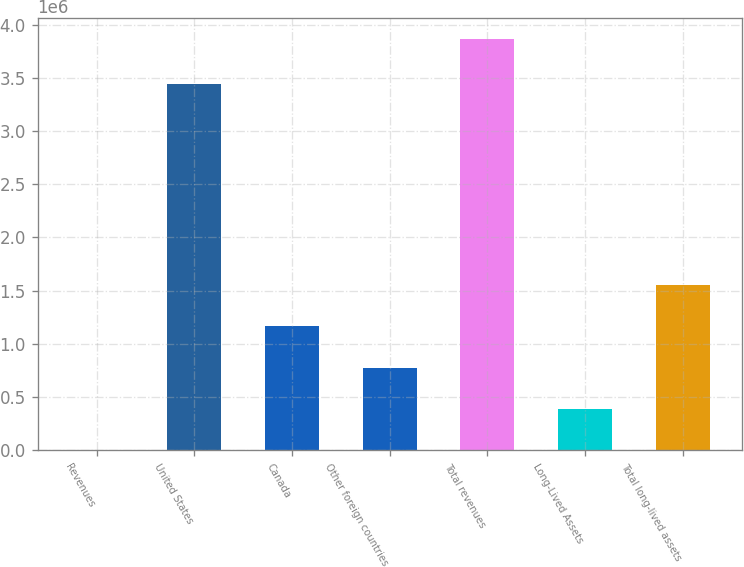<chart> <loc_0><loc_0><loc_500><loc_500><bar_chart><fcel>Revenues<fcel>United States<fcel>Canada<fcel>Other foreign countries<fcel>Total revenues<fcel>Long-Lived Assets<fcel>Total long-lived assets<nl><fcel>2015<fcel>3.44114e+06<fcel>1.16217e+06<fcel>775449<fcel>3.86919e+06<fcel>388732<fcel>1.54888e+06<nl></chart> 